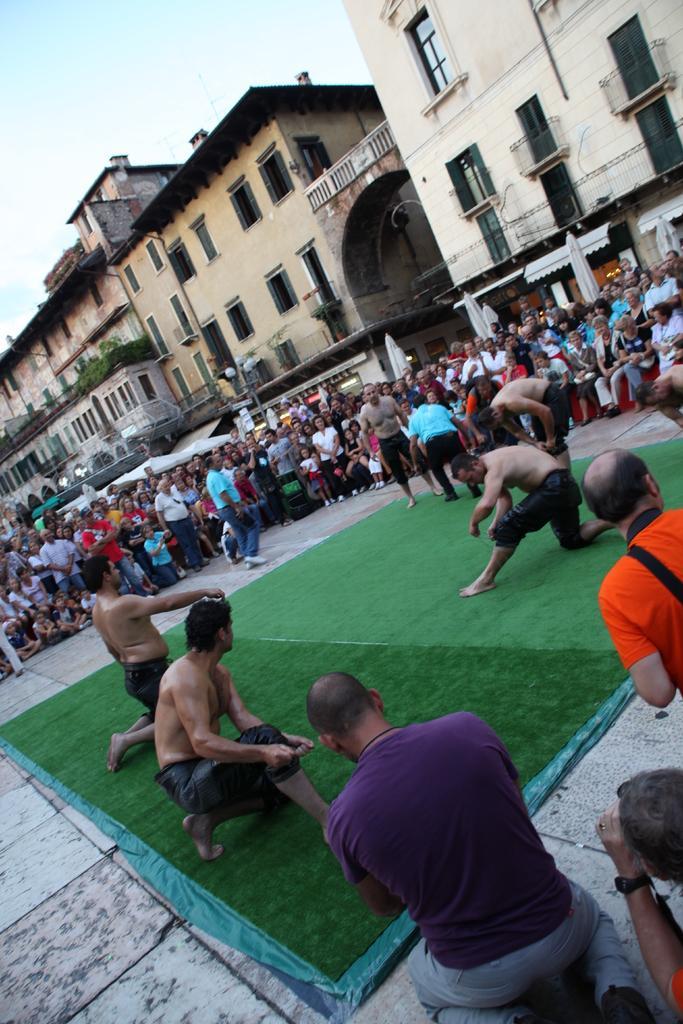Could you give a brief overview of what you see in this image? In this image few persons are on the ground and few persons are standing at the side. At right side there are buildings and street light. On top there is a sky. 